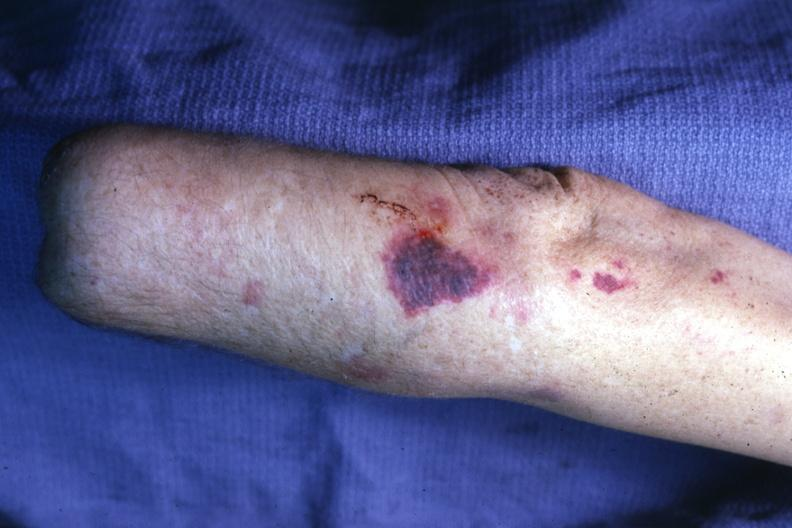what does this image show?
Answer the question using a single word or phrase. Lesion on forearm 